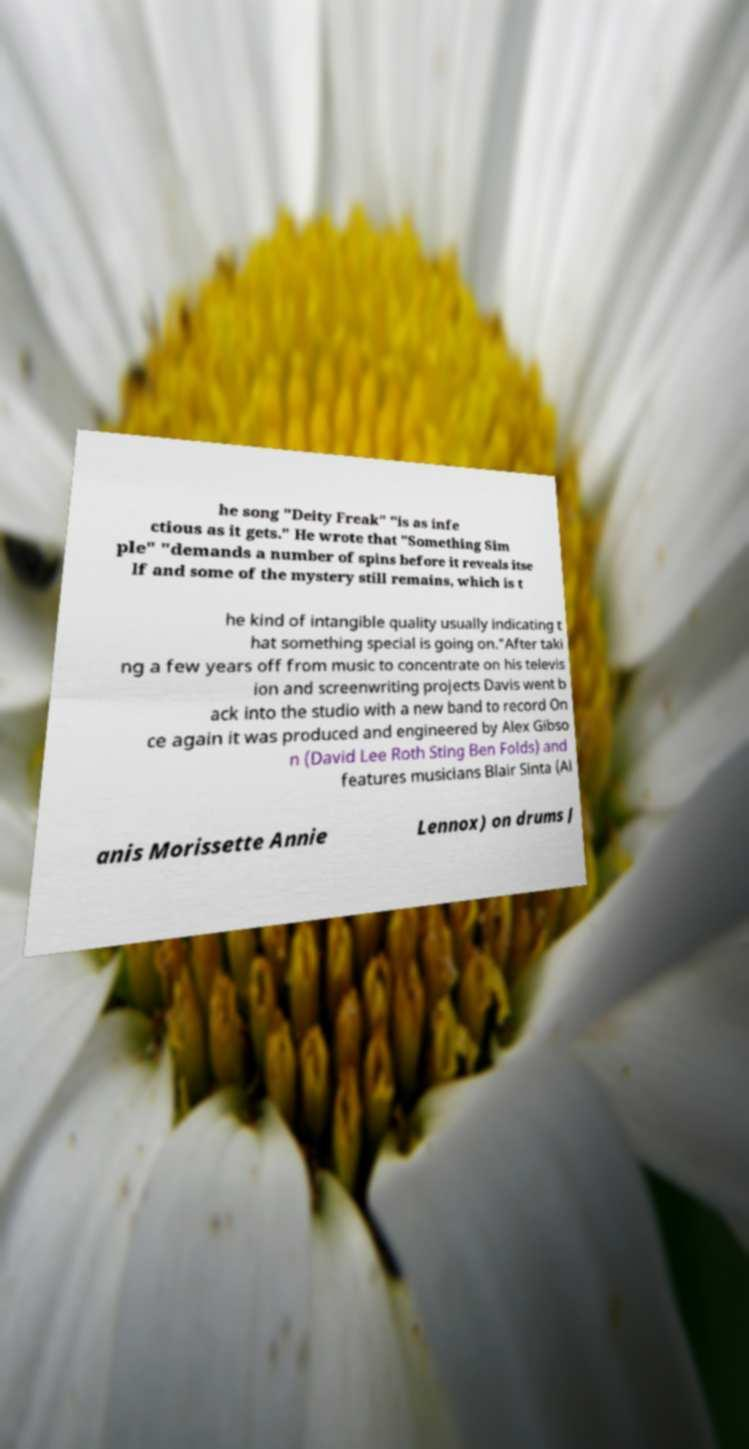Could you extract and type out the text from this image? he song "Deity Freak" "is as infe ctious as it gets." He wrote that "Something Sim ple" "demands a number of spins before it reveals itse lf and some of the mystery still remains, which is t he kind of intangible quality usually indicating t hat something special is going on."After taki ng a few years off from music to concentrate on his televis ion and screenwriting projects Davis went b ack into the studio with a new band to record On ce again it was produced and engineered by Alex Gibso n (David Lee Roth Sting Ben Folds) and features musicians Blair Sinta (Al anis Morissette Annie Lennox) on drums J 